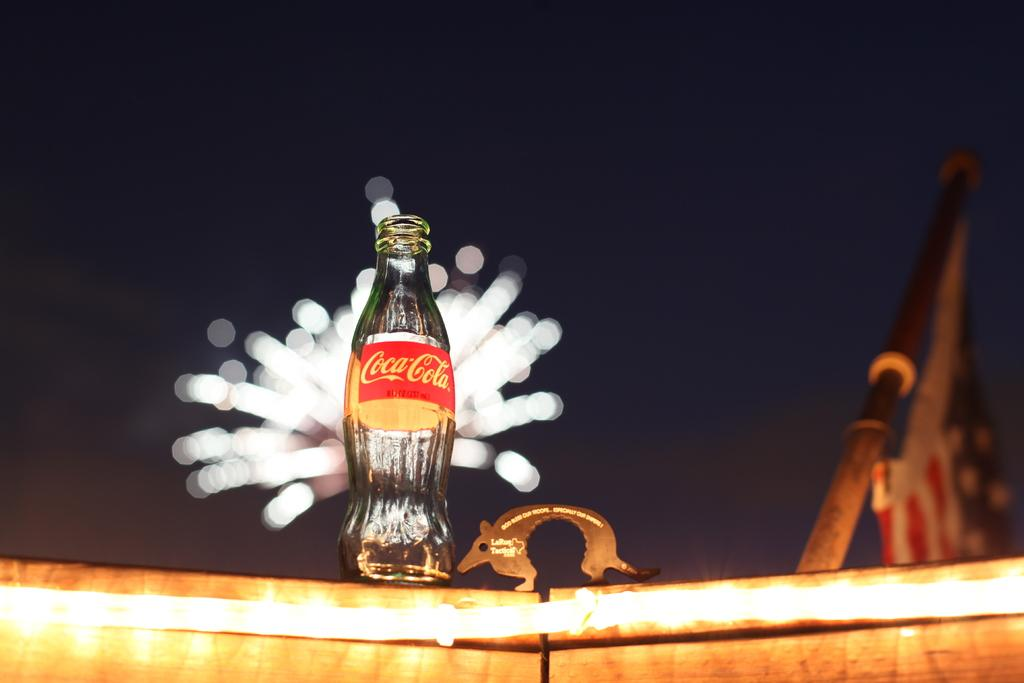<image>
Create a compact narrative representing the image presented. A glass bottle of Coca Cola sitting outside at night. 